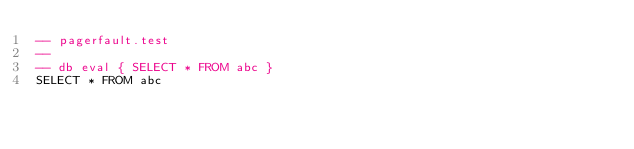Convert code to text. <code><loc_0><loc_0><loc_500><loc_500><_SQL_>-- pagerfault.test
-- 
-- db eval { SELECT * FROM abc }
SELECT * FROM abc</code> 